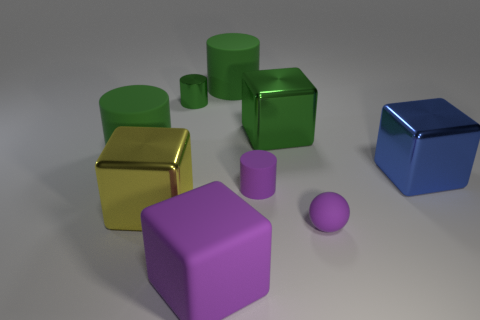What material is the cylinder that is in front of the blue metallic block?
Your response must be concise. Rubber. What material is the blue block that is the same size as the yellow block?
Offer a very short reply. Metal. There is a purple block to the left of the blue shiny object that is in front of the big cylinder to the left of the big purple rubber object; what is it made of?
Give a very brief answer. Rubber. There is a green metallic object on the right side of the green shiny cylinder; is its size the same as the ball?
Keep it short and to the point. No. Is the number of small yellow shiny cylinders greater than the number of metallic cylinders?
Provide a short and direct response. No. What number of big objects are purple balls or yellow cubes?
Keep it short and to the point. 1. What number of other objects are there of the same color as the tiny matte cylinder?
Your response must be concise. 2. What number of other purple spheres have the same material as the tiny ball?
Offer a very short reply. 0. Is the color of the small rubber object that is to the left of the ball the same as the big matte cube?
Your response must be concise. Yes. What number of purple things are either metallic blocks or large things?
Ensure brevity in your answer.  1. 